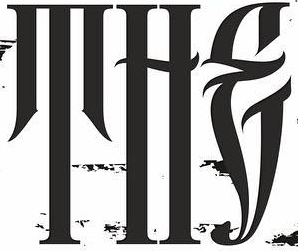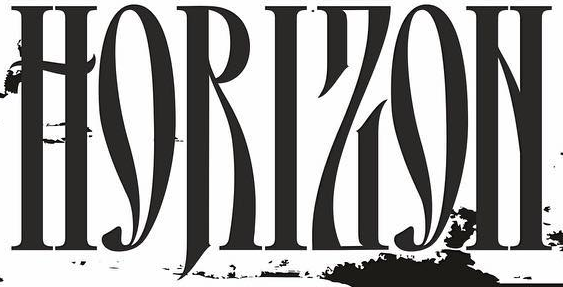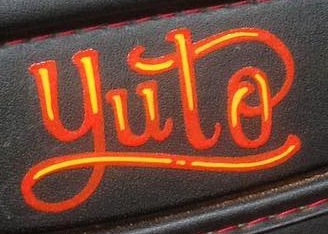Read the text from these images in sequence, separated by a semicolon. THE; HORIZON; yuto 